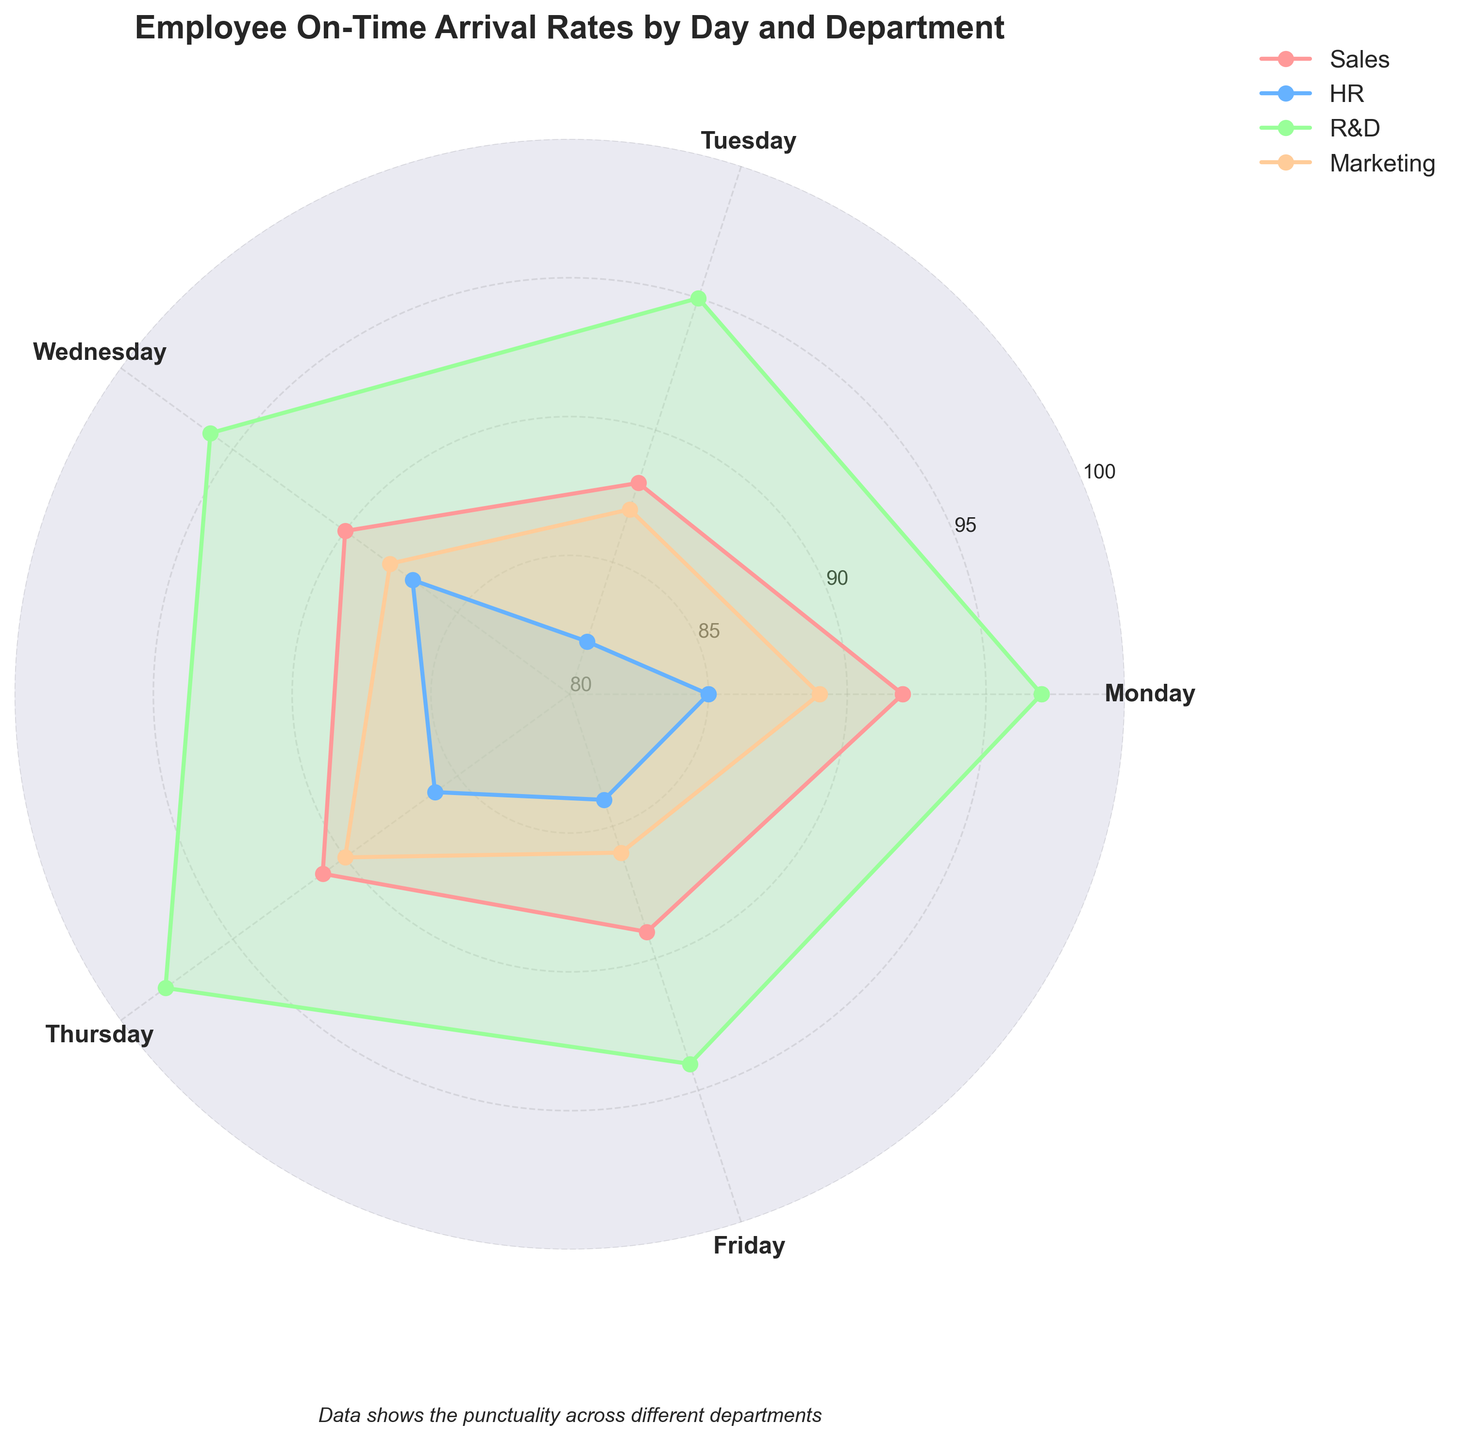What's the title of the figure? The title is displayed prominently at the top of the chart. By reading the chart, we can see it is: "Employee On-Time Arrival Rates by Day and Department"
Answer: Employee On-Time Arrival Rates by Day and Department Which department has the highest on-time arrival rate on Thursday? We can examine the plot to see which department has the highest value on Thursday. According to the chart, R&D has the highest on-time arrival rate on Thursday.
Answer: R&D On which day does the Sales department have its lowest on-time arrival rate? By observing the plot and comparing the values for each day in the Sales department, the lowest on-time arrival rate for Sales is on Tuesday.
Answer: Tuesday What is the average on-time arrival rate for the Marketing department for the week? To find the average, sum the on-time arrival rates for Marketing: 89 (Mon) + 87 (Tue) + 88 (Wed) + 90 (Thu) + 86 (Fri) = 440, then divide by the number of days: 440/5 = 88.
Answer: 88 Does any department have a consistent on-time rate across all days of the week? By checking if any department maintains the same rate for all days, we find that no department has a completely consistent rate across the week.
Answer: No Which department has the widest range of on-time arrival rates? The range is calculated by subtracting the lowest from the highest value for each department. Sales: 92-88=4, HR: 87-82=5, R&D: 98-94=4, Marketing: 90-86=4. HR has the widest range.
Answer: HR How many departments are displayed in the figure? By observing the different colored polygons and the legend, we can see that there are four departments represented.
Answer: 4 Which day of the week has the highest overall on-time arrival rate across all departments? By comparing the highest points on each day across all departments, Thursday has the highest individual rates with R&D reaching 98%.
Answer: Thursday Between Monday and Friday, which day shows the lowest average on-time arrival rate across all departments? Calculate the average on-time rate for each day by summing the rates then dividing by the number of departments. Monday: (92+85+97+89)/4 = 90.75, Friday: (89+84+94+86)/4 = 88.25. Friday has the lowest.
Answer: Friday 